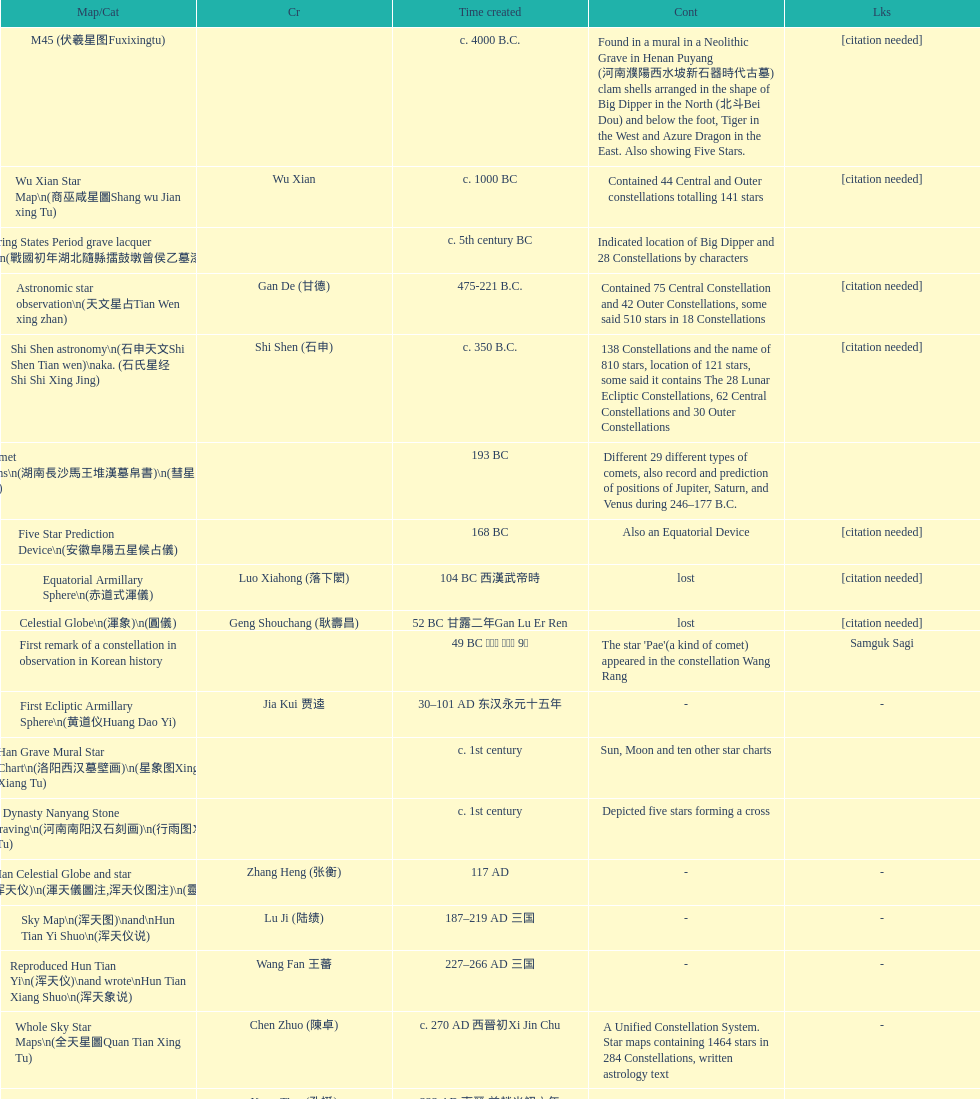Which map or catalog was created last? Sky in Google Earth KML. 